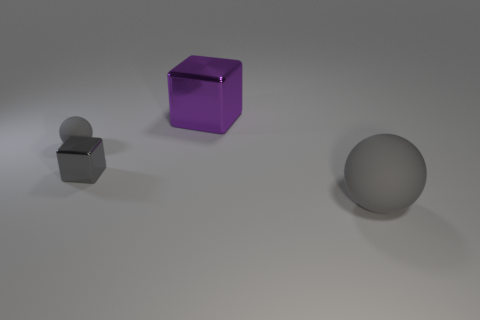The big gray object is what shape?
Keep it short and to the point. Sphere. How many small objects are the same color as the large metallic thing?
Your answer should be very brief. 0. There is a gray sphere that is to the left of the big thing behind the matte object that is left of the large gray thing; what is its material?
Provide a short and direct response. Rubber. What number of gray things are either tiny metallic things or cubes?
Provide a succinct answer. 1. There is a rubber object behind the gray matte thing in front of the rubber object on the left side of the purple block; what size is it?
Your answer should be compact. Small. What size is the other shiny object that is the same shape as the gray shiny object?
Offer a terse response. Large. How many large objects are either blue metallic balls or spheres?
Offer a very short reply. 1. Are the ball to the right of the small gray matte sphere and the gray ball left of the gray block made of the same material?
Your response must be concise. Yes. There is a thing on the right side of the purple block; what is it made of?
Give a very brief answer. Rubber. What number of rubber things are tiny gray things or tiny gray blocks?
Offer a very short reply. 1. 